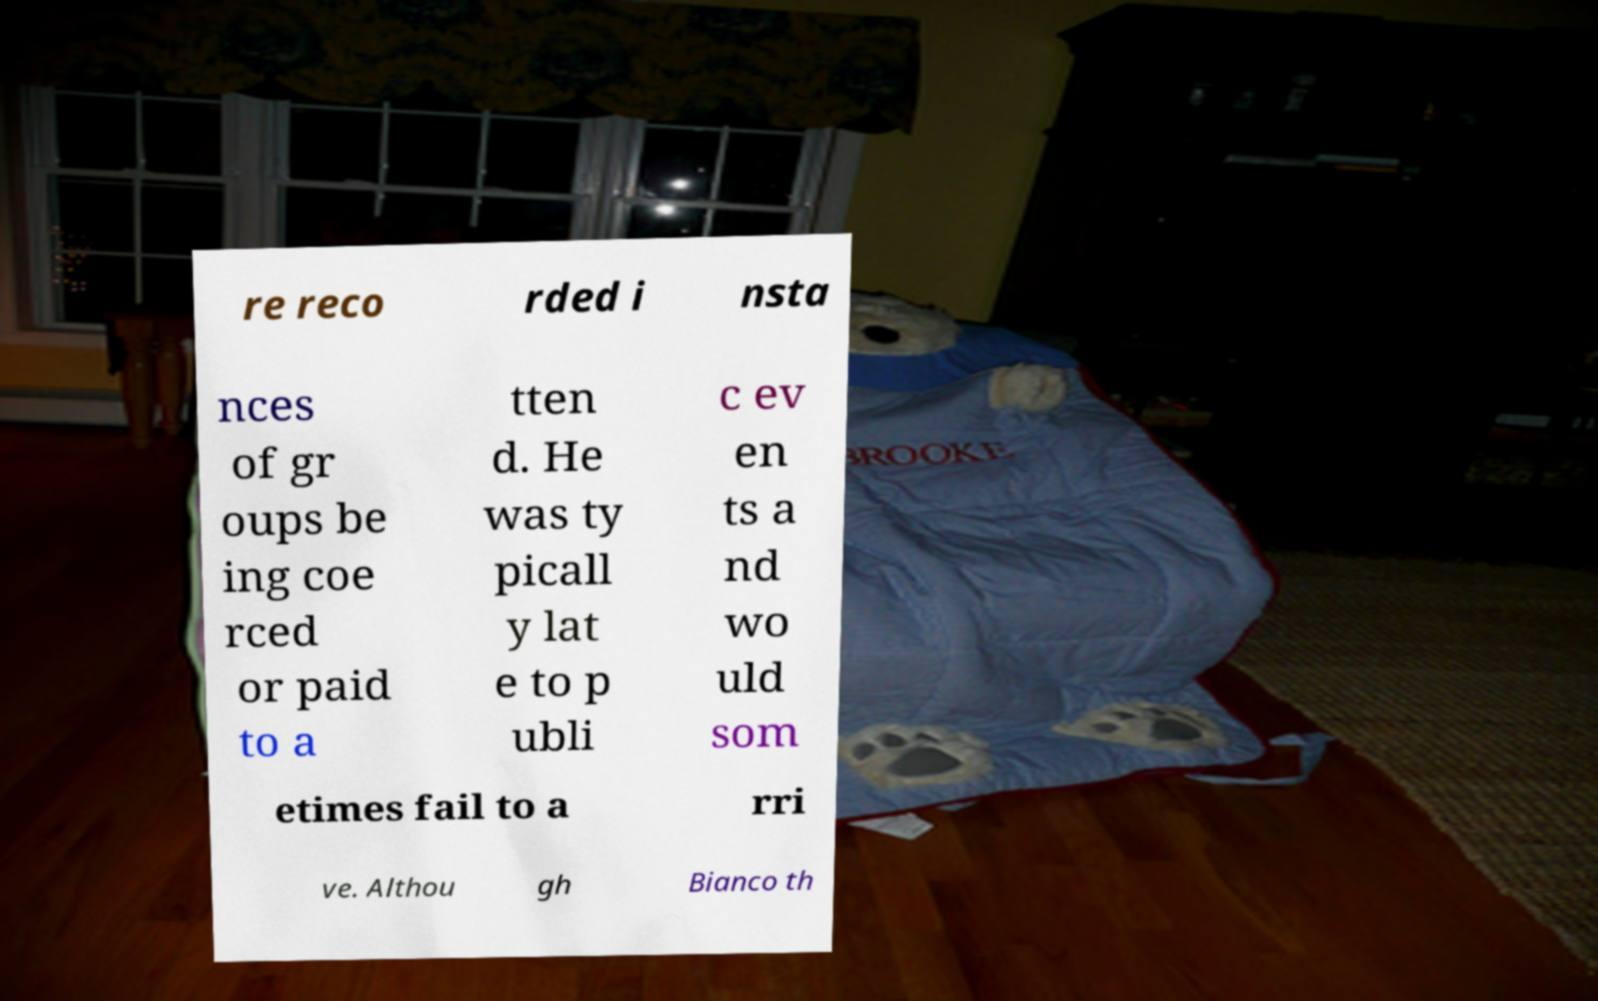I need the written content from this picture converted into text. Can you do that? re reco rded i nsta nces of gr oups be ing coe rced or paid to a tten d. He was ty picall y lat e to p ubli c ev en ts a nd wo uld som etimes fail to a rri ve. Althou gh Bianco th 